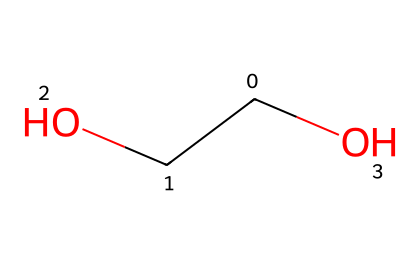What is the functional group present in this chemical? The presence of an alcohol functional group is indicated by the -OH group attached to the carbon chain. This can be identified by recognizing the hydroxyl group in the chemical structure.
Answer: alcohol How many carbon atoms are in this chemical? By analyzing the SMILES notation, the first part 'C(CO)' shows there are two carbon atoms in the main chain.
Answer: two Is this chemical likely to be a solid, liquid, or gas at room temperature? Considering that this chemical has an alcohol group and moderate molecular weight, it is likely to be a liquid under standard conditions. Alcohols generally have lower boiling points than large hydrocarbons, leading to liquid states.
Answer: liquid What type of polymer structure can be derived from this chemical? This chemical, having a hydroxyl group, can form hydrogen bonds, leading to a networked structure when combined in sufficient quantities, typical of polymers in impact-resistant fabric applications.
Answer: hydroxyl polymer Which property of this chemical might contribute to its behavior as a dilatant suspension? The ability to form a network through hydrogen bonding allows this chemical to resist flow when stress is applied, which is a key characteristic of dilatant fluids. This non-Newtonian behavior is essential for impact resistance in textiles.
Answer: non-Newtonian behavior What is the primary use of dilatant suspensions in textile manufacturing? Dilatant suspensions are primarily used to enhance impact resistance in fabrics, making them suitable for protective clothing and gear, where flexibility and strength under stress are crucial.
Answer: impact resistance 